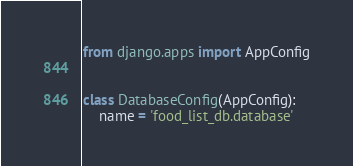<code> <loc_0><loc_0><loc_500><loc_500><_Python_>from django.apps import AppConfig


class DatabaseConfig(AppConfig):
    name = 'food_list_db.database'
</code> 